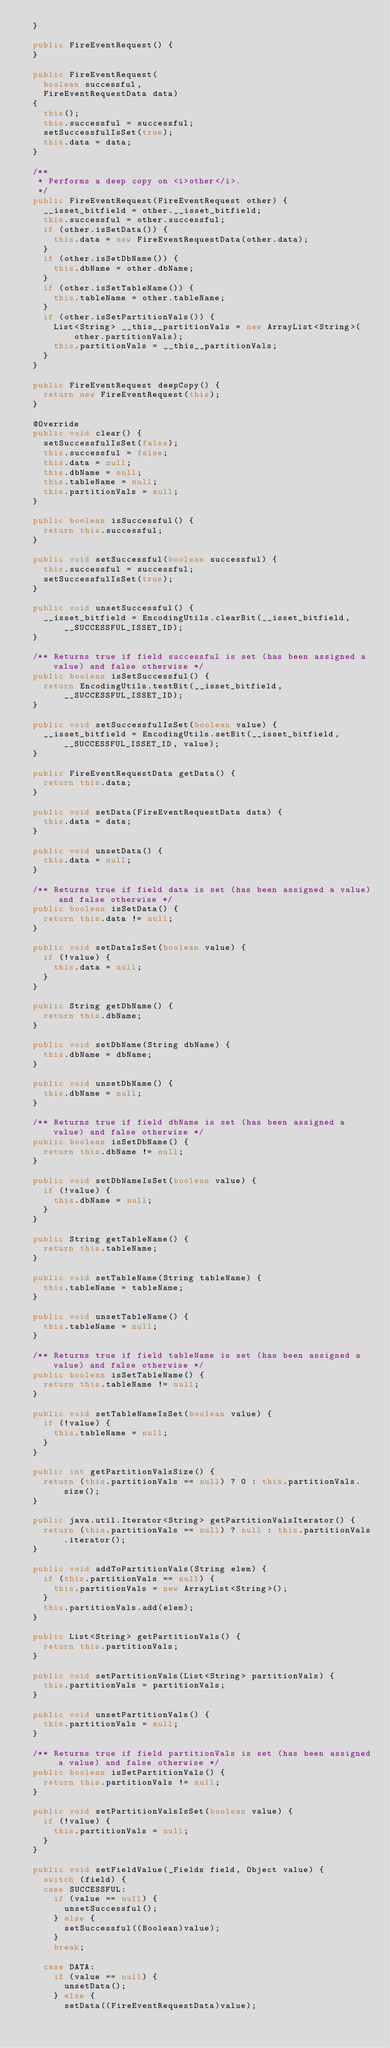Convert code to text. <code><loc_0><loc_0><loc_500><loc_500><_Java_>  }

  public FireEventRequest() {
  }

  public FireEventRequest(
    boolean successful,
    FireEventRequestData data)
  {
    this();
    this.successful = successful;
    setSuccessfulIsSet(true);
    this.data = data;
  }

  /**
   * Performs a deep copy on <i>other</i>.
   */
  public FireEventRequest(FireEventRequest other) {
    __isset_bitfield = other.__isset_bitfield;
    this.successful = other.successful;
    if (other.isSetData()) {
      this.data = new FireEventRequestData(other.data);
    }
    if (other.isSetDbName()) {
      this.dbName = other.dbName;
    }
    if (other.isSetTableName()) {
      this.tableName = other.tableName;
    }
    if (other.isSetPartitionVals()) {
      List<String> __this__partitionVals = new ArrayList<String>(other.partitionVals);
      this.partitionVals = __this__partitionVals;
    }
  }

  public FireEventRequest deepCopy() {
    return new FireEventRequest(this);
  }

  @Override
  public void clear() {
    setSuccessfulIsSet(false);
    this.successful = false;
    this.data = null;
    this.dbName = null;
    this.tableName = null;
    this.partitionVals = null;
  }

  public boolean isSuccessful() {
    return this.successful;
  }

  public void setSuccessful(boolean successful) {
    this.successful = successful;
    setSuccessfulIsSet(true);
  }

  public void unsetSuccessful() {
    __isset_bitfield = EncodingUtils.clearBit(__isset_bitfield, __SUCCESSFUL_ISSET_ID);
  }

  /** Returns true if field successful is set (has been assigned a value) and false otherwise */
  public boolean isSetSuccessful() {
    return EncodingUtils.testBit(__isset_bitfield, __SUCCESSFUL_ISSET_ID);
  }

  public void setSuccessfulIsSet(boolean value) {
    __isset_bitfield = EncodingUtils.setBit(__isset_bitfield, __SUCCESSFUL_ISSET_ID, value);
  }

  public FireEventRequestData getData() {
    return this.data;
  }

  public void setData(FireEventRequestData data) {
    this.data = data;
  }

  public void unsetData() {
    this.data = null;
  }

  /** Returns true if field data is set (has been assigned a value) and false otherwise */
  public boolean isSetData() {
    return this.data != null;
  }

  public void setDataIsSet(boolean value) {
    if (!value) {
      this.data = null;
    }
  }

  public String getDbName() {
    return this.dbName;
  }

  public void setDbName(String dbName) {
    this.dbName = dbName;
  }

  public void unsetDbName() {
    this.dbName = null;
  }

  /** Returns true if field dbName is set (has been assigned a value) and false otherwise */
  public boolean isSetDbName() {
    return this.dbName != null;
  }

  public void setDbNameIsSet(boolean value) {
    if (!value) {
      this.dbName = null;
    }
  }

  public String getTableName() {
    return this.tableName;
  }

  public void setTableName(String tableName) {
    this.tableName = tableName;
  }

  public void unsetTableName() {
    this.tableName = null;
  }

  /** Returns true if field tableName is set (has been assigned a value) and false otherwise */
  public boolean isSetTableName() {
    return this.tableName != null;
  }

  public void setTableNameIsSet(boolean value) {
    if (!value) {
      this.tableName = null;
    }
  }

  public int getPartitionValsSize() {
    return (this.partitionVals == null) ? 0 : this.partitionVals.size();
  }

  public java.util.Iterator<String> getPartitionValsIterator() {
    return (this.partitionVals == null) ? null : this.partitionVals.iterator();
  }

  public void addToPartitionVals(String elem) {
    if (this.partitionVals == null) {
      this.partitionVals = new ArrayList<String>();
    }
    this.partitionVals.add(elem);
  }

  public List<String> getPartitionVals() {
    return this.partitionVals;
  }

  public void setPartitionVals(List<String> partitionVals) {
    this.partitionVals = partitionVals;
  }

  public void unsetPartitionVals() {
    this.partitionVals = null;
  }

  /** Returns true if field partitionVals is set (has been assigned a value) and false otherwise */
  public boolean isSetPartitionVals() {
    return this.partitionVals != null;
  }

  public void setPartitionValsIsSet(boolean value) {
    if (!value) {
      this.partitionVals = null;
    }
  }

  public void setFieldValue(_Fields field, Object value) {
    switch (field) {
    case SUCCESSFUL:
      if (value == null) {
        unsetSuccessful();
      } else {
        setSuccessful((Boolean)value);
      }
      break;

    case DATA:
      if (value == null) {
        unsetData();
      } else {
        setData((FireEventRequestData)value);</code> 